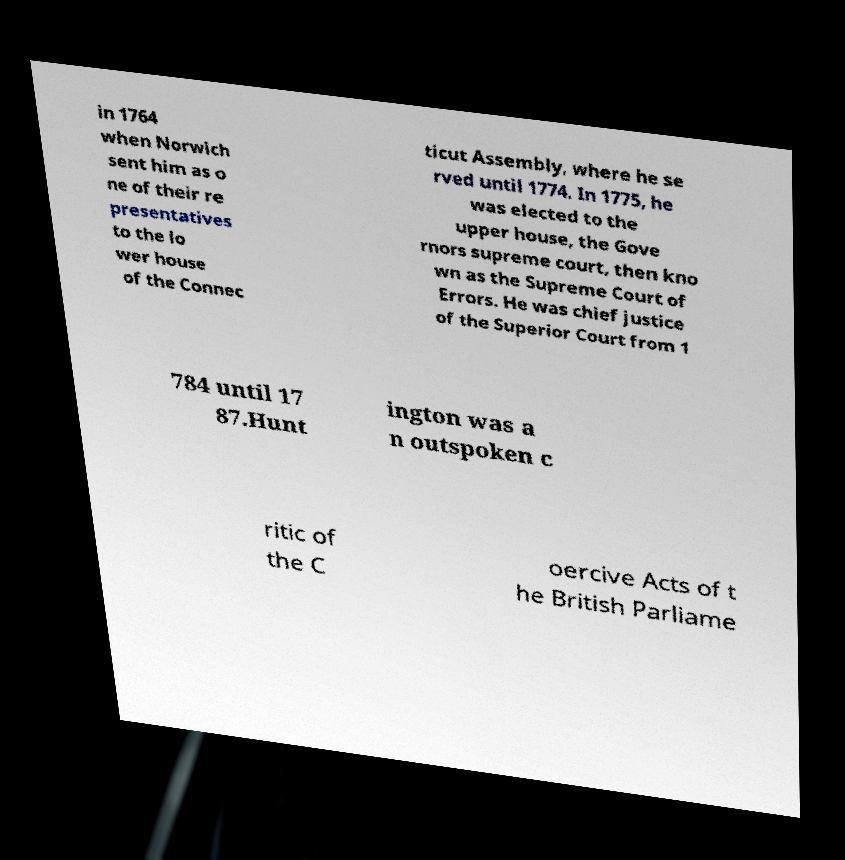Can you read and provide the text displayed in the image?This photo seems to have some interesting text. Can you extract and type it out for me? in 1764 when Norwich sent him as o ne of their re presentatives to the lo wer house of the Connec ticut Assembly, where he se rved until 1774. In 1775, he was elected to the upper house, the Gove rnors supreme court, then kno wn as the Supreme Court of Errors. He was chief justice of the Superior Court from 1 784 until 17 87.Hunt ington was a n outspoken c ritic of the C oercive Acts of t he British Parliame 